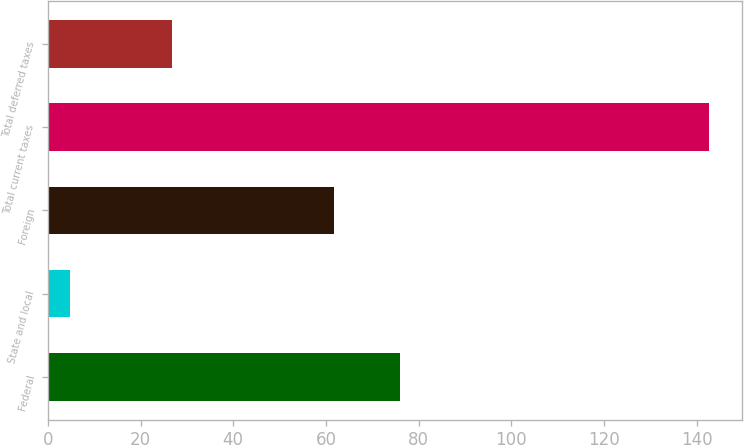<chart> <loc_0><loc_0><loc_500><loc_500><bar_chart><fcel>Federal<fcel>State and local<fcel>Foreign<fcel>Total current taxes<fcel>Total deferred taxes<nl><fcel>76.1<fcel>4.7<fcel>61.8<fcel>142.6<fcel>26.8<nl></chart> 